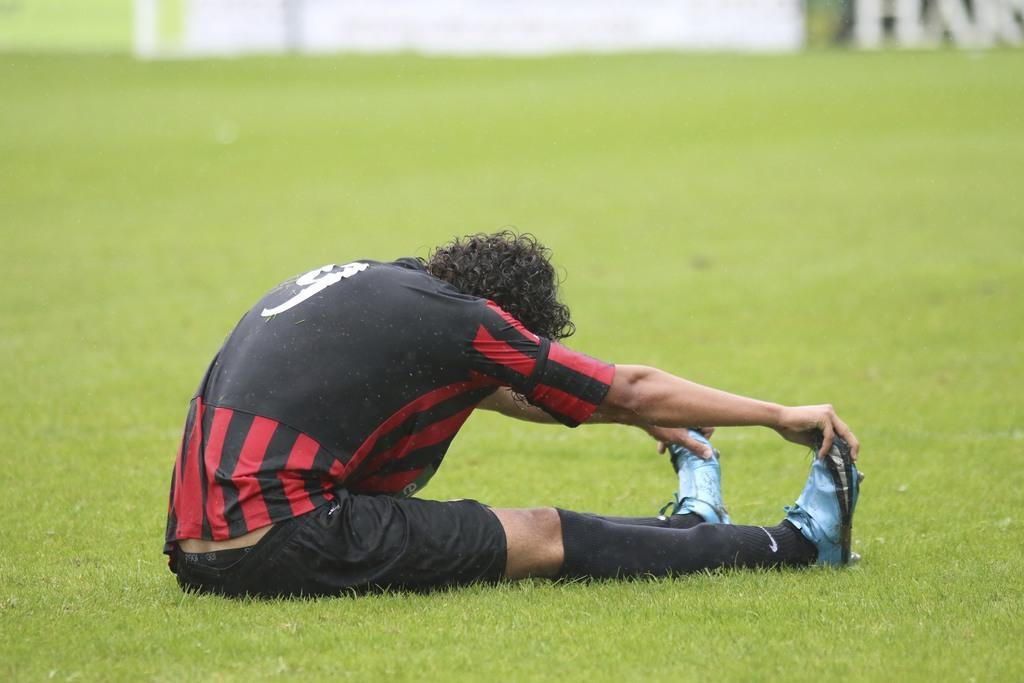How would you summarize this image in a sentence or two? In this image, I can see a person sitting on the grass. At the top of the image, It looks like an object. 